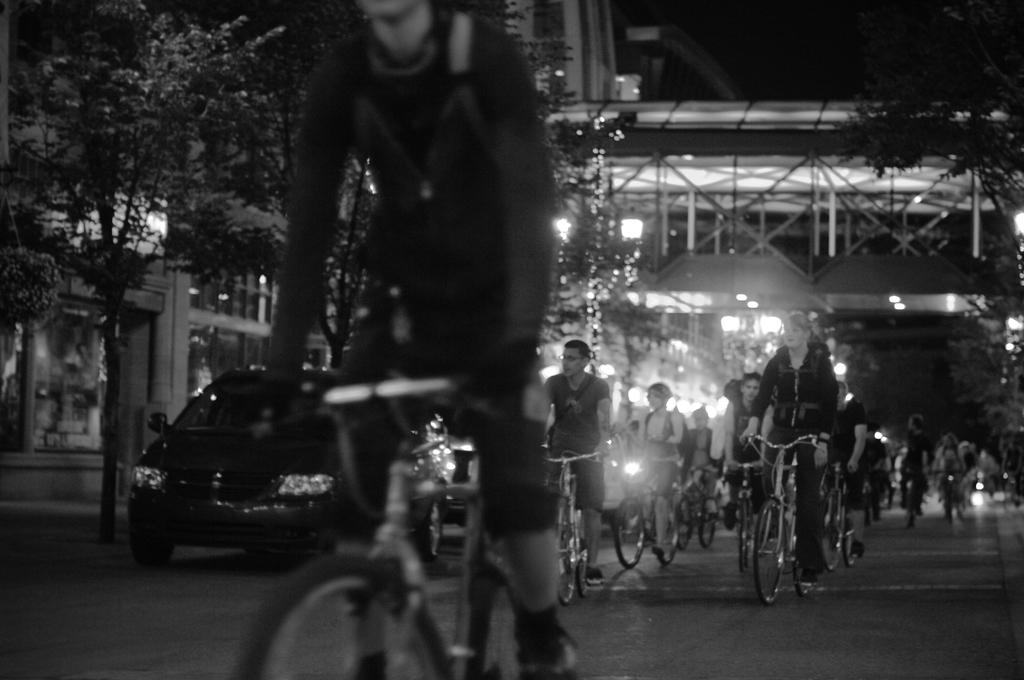What are the people in the image doing? The people in the image are riding bicycles. Where are the people riding their bicycles? They are riding bicycles under a bridge. What else can be seen in the image besides the people on bicycles? There is a building visible in the image, and a car is parked under trees. How much was the payment for the kite in the image? There is no kite present in the image, so there is no payment to discuss. 